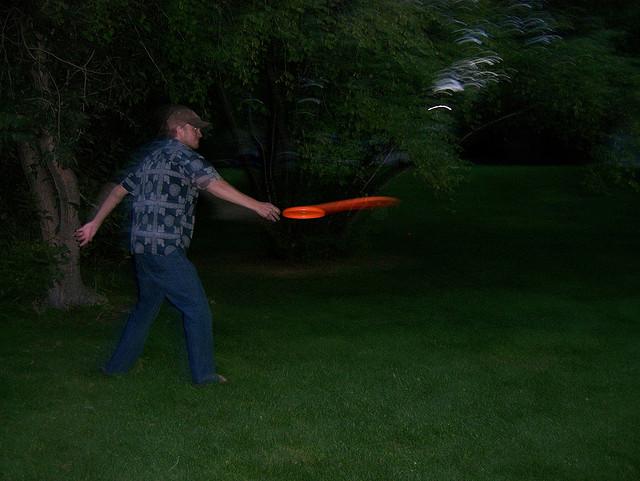Was this picture taken at night?
Write a very short answer. Yes. Is the man running?
Short answer required. No. What color is the man's Hat?
Answer briefly. Brown. Is the Frisbee moving left to right?
Answer briefly. Right. Was this photo taken at a skatepark?
Concise answer only. No. Is the man trying to catch a Frisbee?
Quick response, please. Yes. What color is the man's shirt?
Concise answer only. Blue. Isn't it to dark to play frisbee?
Quick response, please. No. 